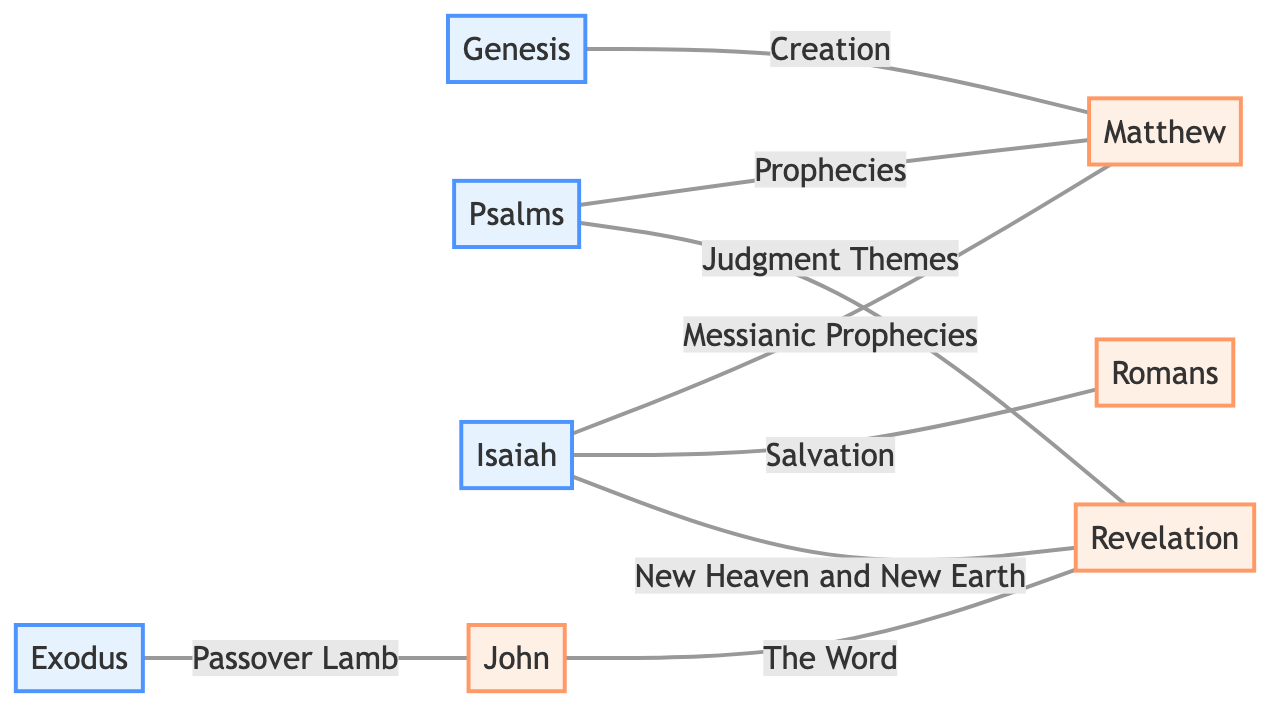What is the total number of nodes in the diagram? The diagram lists eight unique books of the Bible: Genesis, Exodus, Psalms, Isaiah, Matthew, John, Romans, and Revelation. Counting them gives a total of 8 nodes.
Answer: 8 Which book is linked to "Judgment Themes"? The edge labeled "Judgment Themes" connects the node Psalms to Revelation. Therefore, the book linked to this concept is Revelation.
Answer: Revelation What relationship exists between Genesis and Matthew? The edge between Genesis and Matthew is labeled "Creation." This indicates a specific relationship where Genesis references the creation as understood in the context of Matthew.
Answer: Creation How many edges are connected to Isaiah? Isaiah is connected to three edges: to Matthew (Messianic Prophecies), to Romans (Salvation), and to Revelation (New Heaven and New Earth). Counting these edges gives a total of 3.
Answer: 3 What type of Old Testament theme is associated with John? The edge labeled "Passover Lamb" indicates that Exodus relates to John in a theme concerning the Passover Lamb. This theme is significant in the context of salvation and sacrifice.
Answer: Passover Lamb Which two New Testament books have a direct connection through "The Word"? The edge labeled "The Word" connects John to Revelation. Therefore, the two New Testament books that have this connection are John and Revelation.
Answer: John and Revelation What is the commonality between Psalms and Matthew? The edges from Psalms to Matthew both include the label "Prophecies," indicating that Psalms presents prophetic themes that are relevant to the teachings found in Matthew.
Answer: Prophecies Which Old Testament book has the most connections to New Testament books? Isaiah connects to three New Testament books: Matthew (Messianic Prophecies), Romans (Salvation), and Revelation (New Heaven and New Earth). Therefore, Isaiah has the most connections.
Answer: Isaiah 